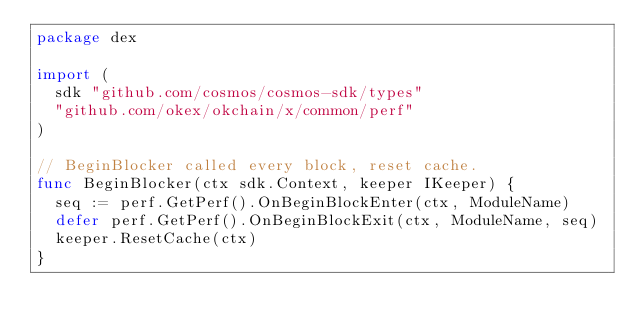<code> <loc_0><loc_0><loc_500><loc_500><_Go_>package dex

import (
	sdk "github.com/cosmos/cosmos-sdk/types"
	"github.com/okex/okchain/x/common/perf"
)

// BeginBlocker called every block, reset cache.
func BeginBlocker(ctx sdk.Context, keeper IKeeper) {
	seq := perf.GetPerf().OnBeginBlockEnter(ctx, ModuleName)
	defer perf.GetPerf().OnBeginBlockExit(ctx, ModuleName, seq)
	keeper.ResetCache(ctx)
}
</code> 